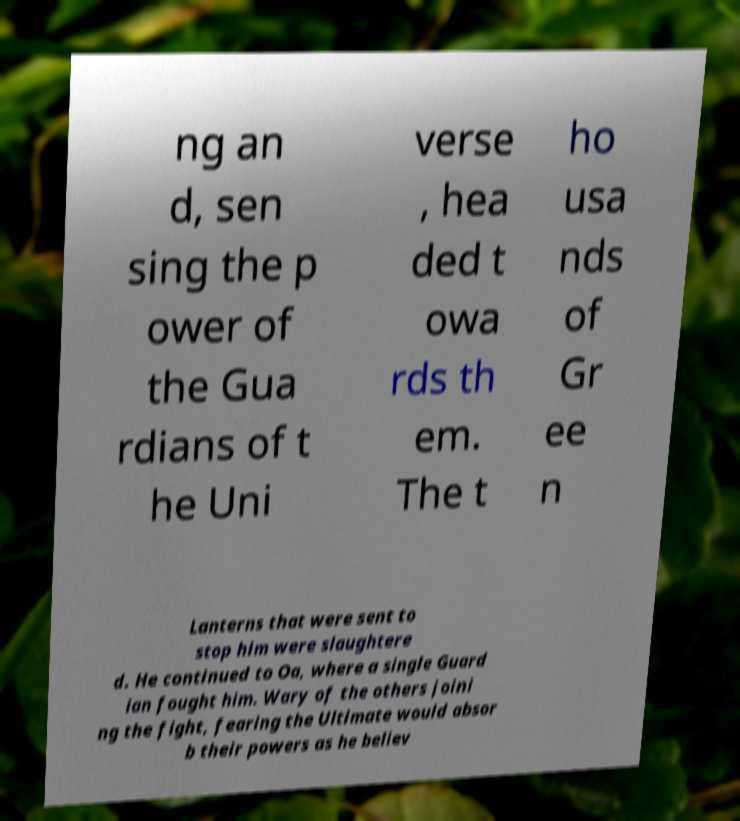What messages or text are displayed in this image? I need them in a readable, typed format. ng an d, sen sing the p ower of the Gua rdians of t he Uni verse , hea ded t owa rds th em. The t ho usa nds of Gr ee n Lanterns that were sent to stop him were slaughtere d. He continued to Oa, where a single Guard ian fought him. Wary of the others joini ng the fight, fearing the Ultimate would absor b their powers as he believ 